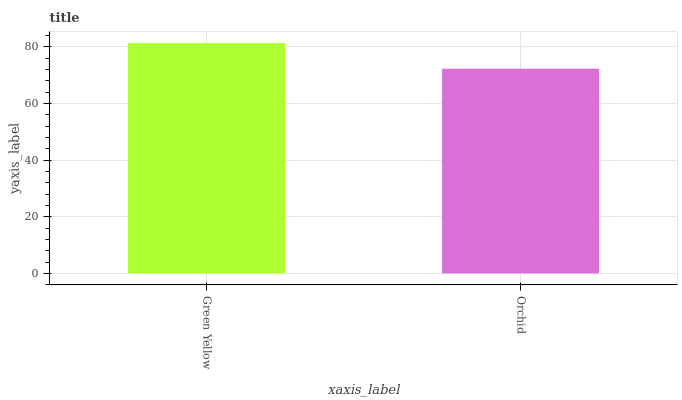Is Orchid the minimum?
Answer yes or no. Yes. Is Green Yellow the maximum?
Answer yes or no. Yes. Is Orchid the maximum?
Answer yes or no. No. Is Green Yellow greater than Orchid?
Answer yes or no. Yes. Is Orchid less than Green Yellow?
Answer yes or no. Yes. Is Orchid greater than Green Yellow?
Answer yes or no. No. Is Green Yellow less than Orchid?
Answer yes or no. No. Is Green Yellow the high median?
Answer yes or no. Yes. Is Orchid the low median?
Answer yes or no. Yes. Is Orchid the high median?
Answer yes or no. No. Is Green Yellow the low median?
Answer yes or no. No. 